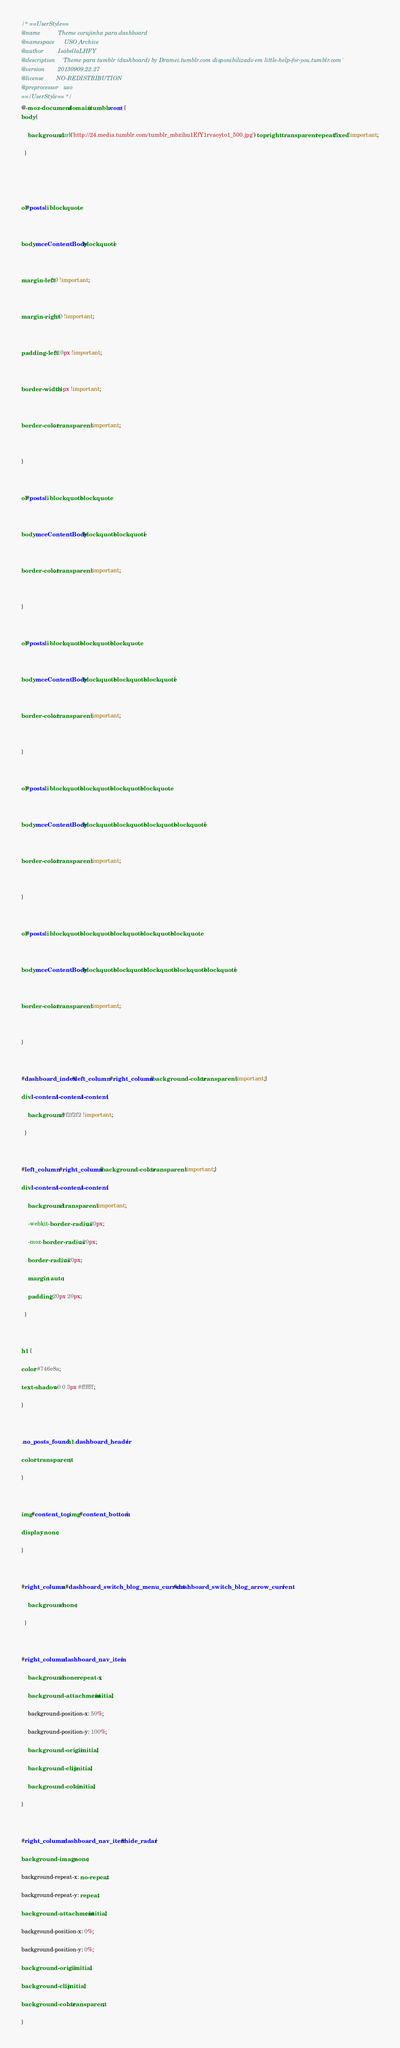<code> <loc_0><loc_0><loc_500><loc_500><_CSS_>/* ==UserStyle==
@name           Theme corujinha para dashboard
@namespace      USO Archive
@author         IsabellaLHFY
@description    `Theme para tumblr (dashboard) by Dramei.tumblr.com disponibilizado em little-help-for-you.tumblr.com`
@version        20130909.22.27
@license        NO-REDISTRIBUTION
@preprocessor   uso
==/UserStyle== */
@-moz-document domain(tumblr.com) {
body {

    background: url('http://24.media.tumblr.com/tumblr_mbzihu1EfY1rvaoyto1_500.jpg') top right transparent repeat fixed !important;

  }





ol#posts li blockquote,



body.mceContentBody blockquote {



margin-left: 0 !important;



margin-right: 0 !important;



padding-left: 10px !important;



border-width: 4px !important;



border-color: transparent !important;



}



ol#posts li blockquote blockquote,



body.mceContentBody blockquote blockquote {



border-color: transparent !important;



}



ol#posts li blockquote blockquote blockquote,



body.mceContentBody blockquote blockquote blockquote {



border-color: transparent !important;



}



ol#posts li blockquote blockquote blockquote blockquote,



body.mceContentBody blockquote blockquote blockquote blockquote {



border-color: transparent !important;



}



ol#posts li blockquote blockquote blockquote blockquote blockquote,



body.mceContentBody blockquote blockquote blockquote blockquote blockquote {



border-color: transparent !important;



}



#dashboard_index #left_column, #right_column {background-color: transparent !important;}

div.l-content.l-content.l-content {

    background: #f2f2f2 !important;

  }



#left_column, #right_column {background-color: transparent !important;}

div.l-content.l-content.l-content {

    background: transparent !important;

    -webkit-border-radius: 20px;

    -moz-border-radius: 20px;

    border-radius: 20px;

    margin: auto;

    padding: 20px 20px;

  }



h1 {

color: #746e8a;

text-shadow: 0 0 3px #ffffff;

}



.no_posts_found, h1.dashboard_header {

color: transparent;

}



img#content_top, img#content_bottom {

display: none;

}



#right_column a#dashboard_switch_blog_menu_current #dashboard_switch_blog_arrow_current {

    background: none;

  }



#right_column .dashboard_nav_item {

    background: none repeat-x;

    background-attachment: initial;

    background-position-x: 50%;

    background-position-y: 100%;

    background-origin: initial;

    background-clip: initial;

    background-color: initial;

}



#right_column .dashboard_nav_item #hide_radar {

background-image: none;

background-repeat-x: no-repeat;

background-repeat-y: repeat;

background-attachment: initial;

background-position-x: 0%;

background-position-y: 0%;

background-origin: initial;

background-clip: initial;

background-color: transparent;

}


</code> 